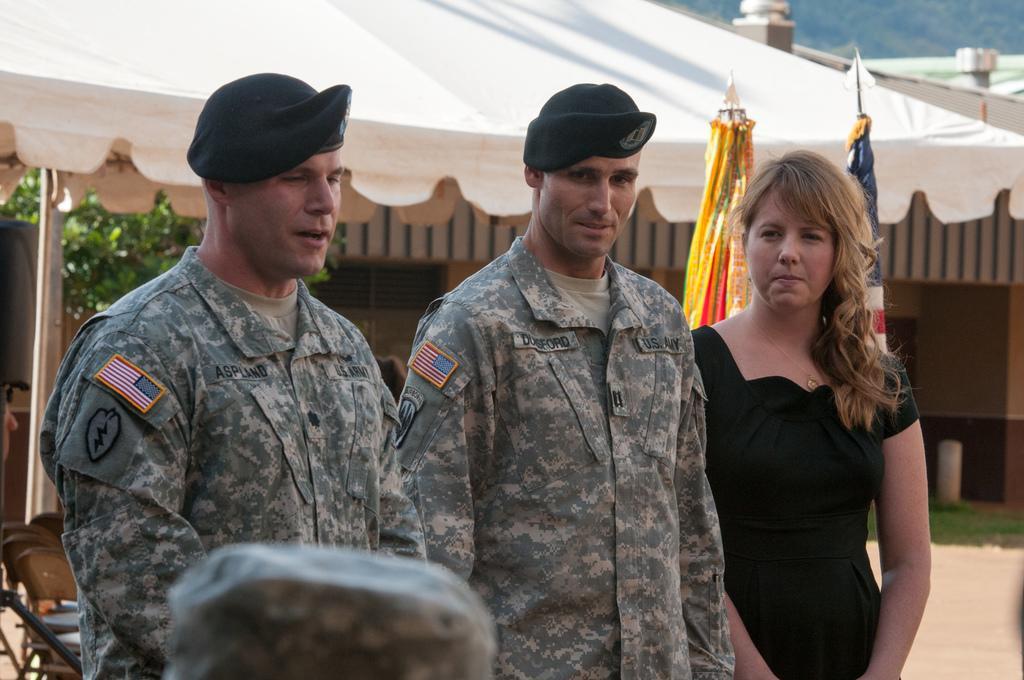Could you give a brief overview of what you see in this image? In this image I can see there are two men and a woman standing and the men are wearing caps, army uniforms and there is a woman standing on the right side and there are two flags in the backdrop, a tent and there is a tree in the backdrop. 